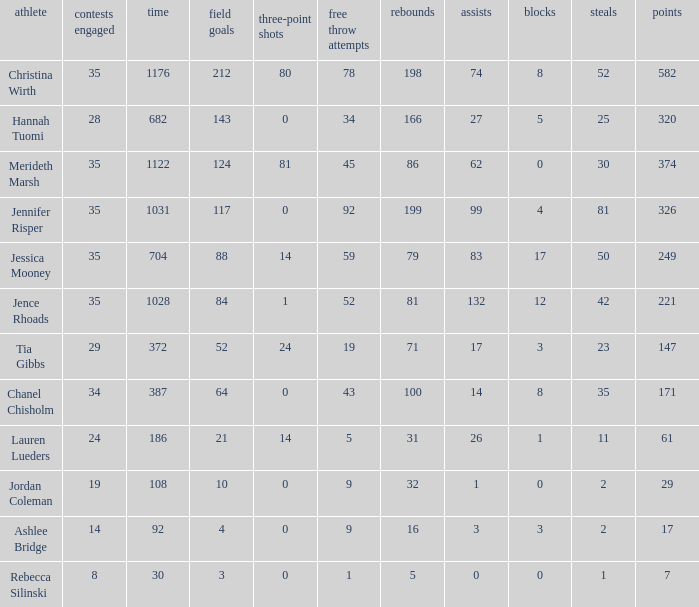What is the lowest number of games played by the player with 50 steals? 35.0. 